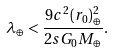<formula> <loc_0><loc_0><loc_500><loc_500>\lambda _ { \oplus } < \frac { 9 c ^ { 2 } ( r _ { 0 } ) _ { \oplus } ^ { 2 } } { 2 s G _ { 0 } M _ { \oplus } } .</formula> 